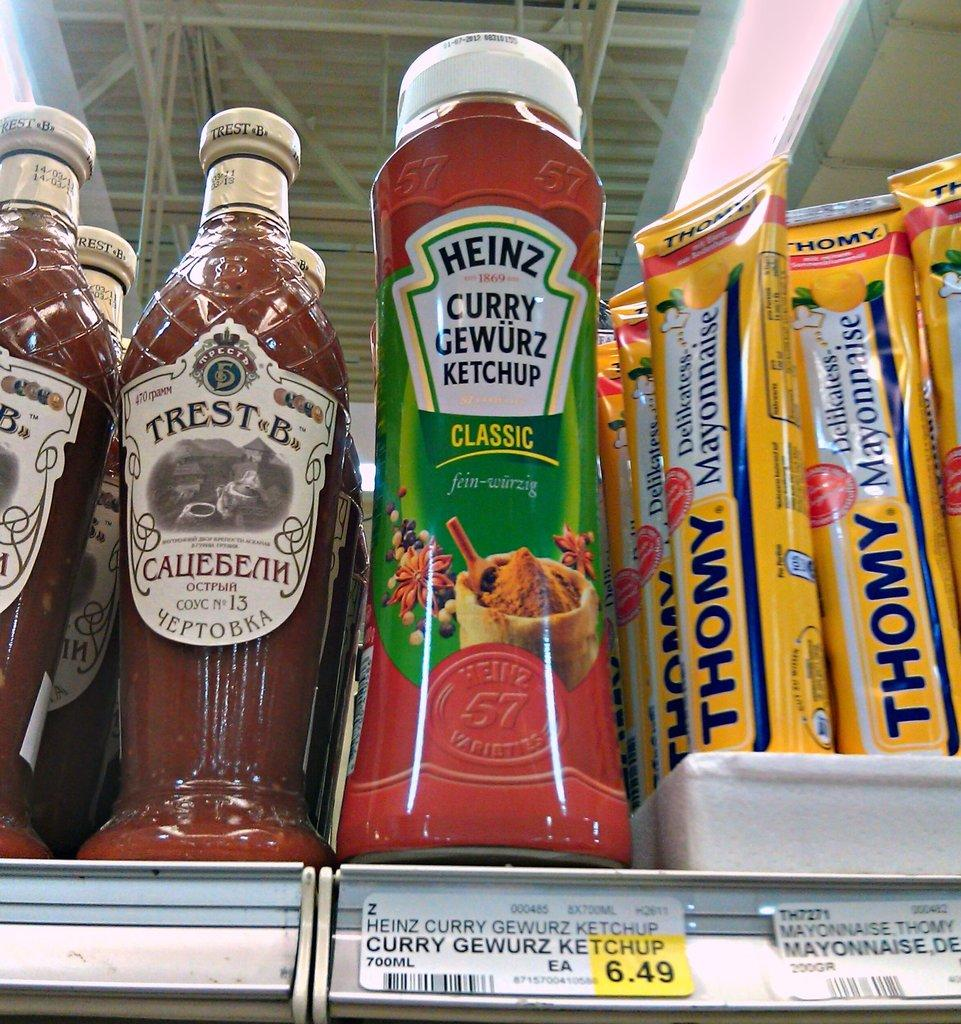<image>
Create a compact narrative representing the image presented. The Heinz ketchup that is sitting on the shelf costs $6.49. 